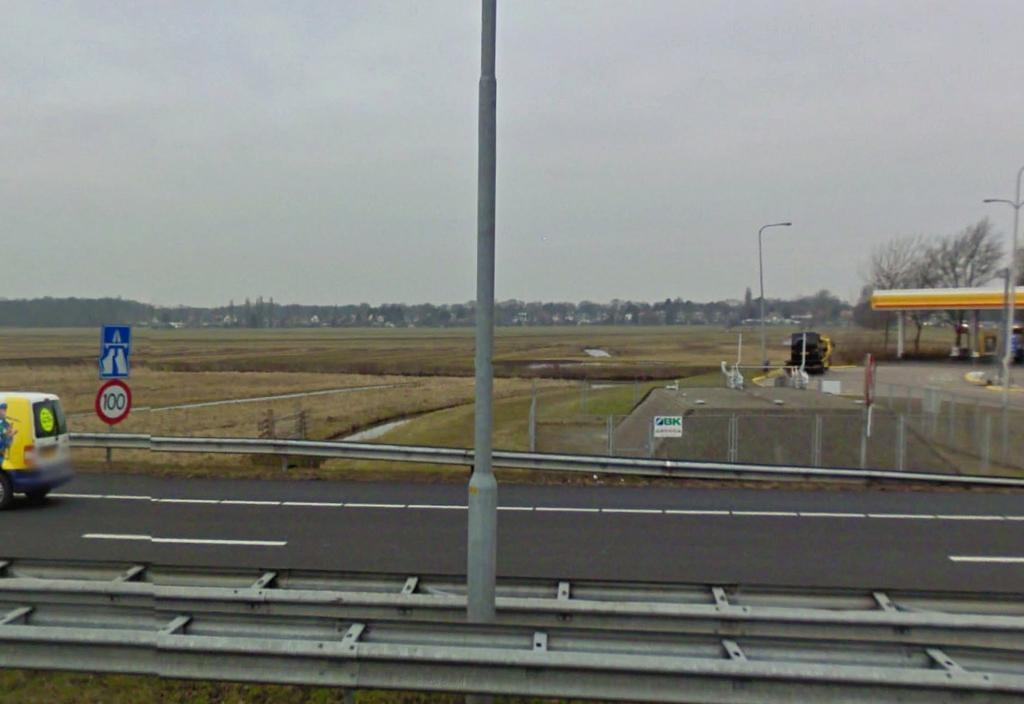Could you give a brief overview of what you see in this image? In this image there is a road, on that road there is a vehicle, behind the road there are fields and there is a gas station in middle there is a pole. 